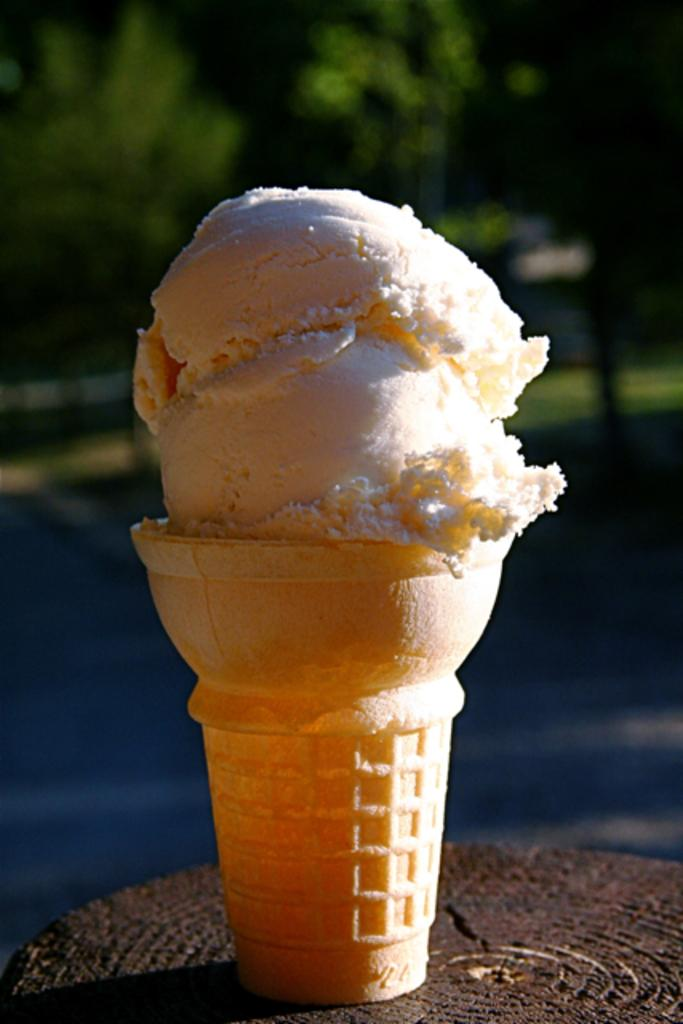What is the main subject of the image? The main subject of the image is an ice cream. What is the ice cream placed on? The ice cream is on a wooden object. What can be seen in the background of the image? There are trees visible in the background of the image. Can you tell me what the people in the image are arguing about? There are no people present in the image, so there is no argument to be observed. How many bites have been taken out of the ice cream in the image? The image does not show any bites taken out of the ice cream, so it cannot be determined. 